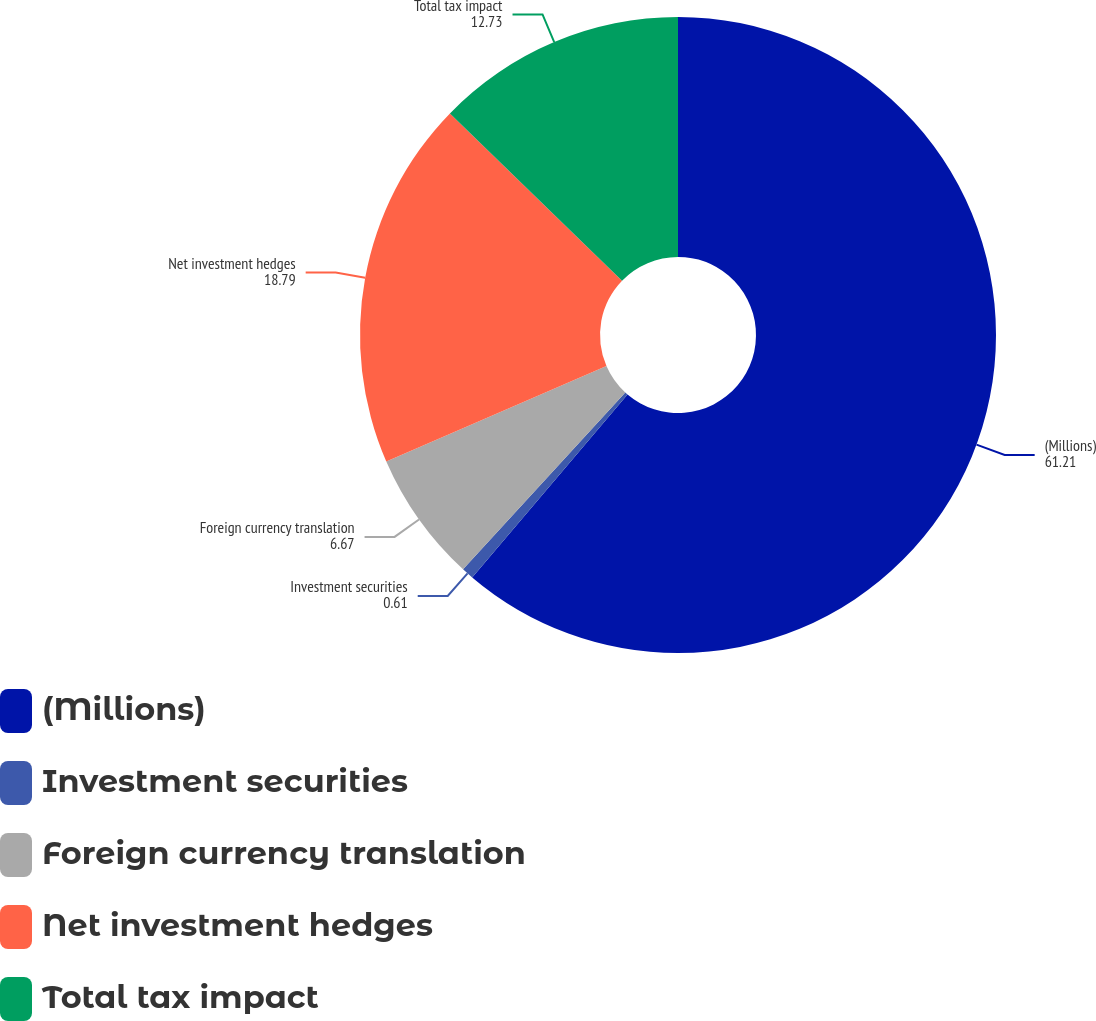<chart> <loc_0><loc_0><loc_500><loc_500><pie_chart><fcel>(Millions)<fcel>Investment securities<fcel>Foreign currency translation<fcel>Net investment hedges<fcel>Total tax impact<nl><fcel>61.21%<fcel>0.61%<fcel>6.67%<fcel>18.79%<fcel>12.73%<nl></chart> 